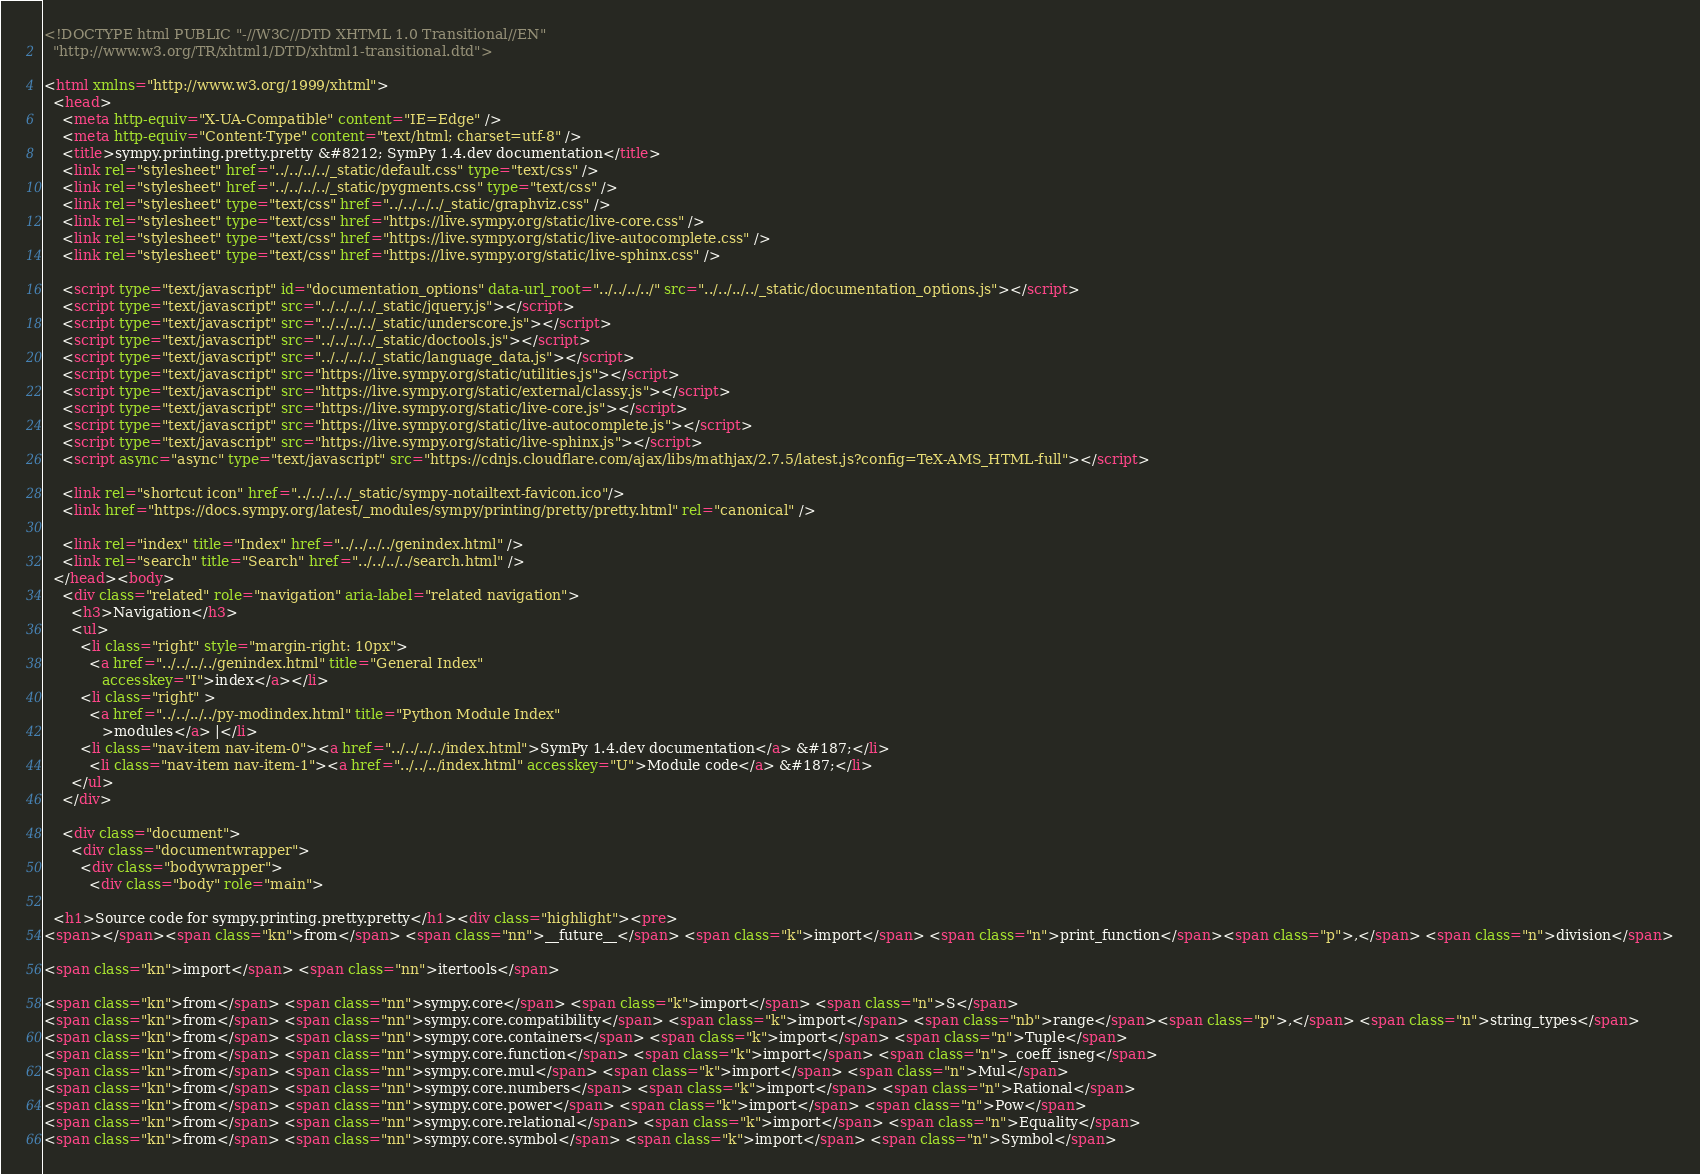<code> <loc_0><loc_0><loc_500><loc_500><_HTML_>
<!DOCTYPE html PUBLIC "-//W3C//DTD XHTML 1.0 Transitional//EN"
  "http://www.w3.org/TR/xhtml1/DTD/xhtml1-transitional.dtd">

<html xmlns="http://www.w3.org/1999/xhtml">
  <head>
    <meta http-equiv="X-UA-Compatible" content="IE=Edge" />
    <meta http-equiv="Content-Type" content="text/html; charset=utf-8" />
    <title>sympy.printing.pretty.pretty &#8212; SymPy 1.4.dev documentation</title>
    <link rel="stylesheet" href="../../../../_static/default.css" type="text/css" />
    <link rel="stylesheet" href="../../../../_static/pygments.css" type="text/css" />
    <link rel="stylesheet" type="text/css" href="../../../../_static/graphviz.css" />
    <link rel="stylesheet" type="text/css" href="https://live.sympy.org/static/live-core.css" />
    <link rel="stylesheet" type="text/css" href="https://live.sympy.org/static/live-autocomplete.css" />
    <link rel="stylesheet" type="text/css" href="https://live.sympy.org/static/live-sphinx.css" />
    
    <script type="text/javascript" id="documentation_options" data-url_root="../../../../" src="../../../../_static/documentation_options.js"></script>
    <script type="text/javascript" src="../../../../_static/jquery.js"></script>
    <script type="text/javascript" src="../../../../_static/underscore.js"></script>
    <script type="text/javascript" src="../../../../_static/doctools.js"></script>
    <script type="text/javascript" src="../../../../_static/language_data.js"></script>
    <script type="text/javascript" src="https://live.sympy.org/static/utilities.js"></script>
    <script type="text/javascript" src="https://live.sympy.org/static/external/classy.js"></script>
    <script type="text/javascript" src="https://live.sympy.org/static/live-core.js"></script>
    <script type="text/javascript" src="https://live.sympy.org/static/live-autocomplete.js"></script>
    <script type="text/javascript" src="https://live.sympy.org/static/live-sphinx.js"></script>
    <script async="async" type="text/javascript" src="https://cdnjs.cloudflare.com/ajax/libs/mathjax/2.7.5/latest.js?config=TeX-AMS_HTML-full"></script>
    
    <link rel="shortcut icon" href="../../../../_static/sympy-notailtext-favicon.ico"/>
    <link href="https://docs.sympy.org/latest/_modules/sympy/printing/pretty/pretty.html" rel="canonical" />
    
    <link rel="index" title="Index" href="../../../../genindex.html" />
    <link rel="search" title="Search" href="../../../../search.html" /> 
  </head><body>
    <div class="related" role="navigation" aria-label="related navigation">
      <h3>Navigation</h3>
      <ul>
        <li class="right" style="margin-right: 10px">
          <a href="../../../../genindex.html" title="General Index"
             accesskey="I">index</a></li>
        <li class="right" >
          <a href="../../../../py-modindex.html" title="Python Module Index"
             >modules</a> |</li>
        <li class="nav-item nav-item-0"><a href="../../../../index.html">SymPy 1.4.dev documentation</a> &#187;</li>
          <li class="nav-item nav-item-1"><a href="../../../index.html" accesskey="U">Module code</a> &#187;</li> 
      </ul>
    </div>  

    <div class="document">
      <div class="documentwrapper">
        <div class="bodywrapper">
          <div class="body" role="main">
            
  <h1>Source code for sympy.printing.pretty.pretty</h1><div class="highlight"><pre>
<span></span><span class="kn">from</span> <span class="nn">__future__</span> <span class="k">import</span> <span class="n">print_function</span><span class="p">,</span> <span class="n">division</span>

<span class="kn">import</span> <span class="nn">itertools</span>

<span class="kn">from</span> <span class="nn">sympy.core</span> <span class="k">import</span> <span class="n">S</span>
<span class="kn">from</span> <span class="nn">sympy.core.compatibility</span> <span class="k">import</span> <span class="nb">range</span><span class="p">,</span> <span class="n">string_types</span>
<span class="kn">from</span> <span class="nn">sympy.core.containers</span> <span class="k">import</span> <span class="n">Tuple</span>
<span class="kn">from</span> <span class="nn">sympy.core.function</span> <span class="k">import</span> <span class="n">_coeff_isneg</span>
<span class="kn">from</span> <span class="nn">sympy.core.mul</span> <span class="k">import</span> <span class="n">Mul</span>
<span class="kn">from</span> <span class="nn">sympy.core.numbers</span> <span class="k">import</span> <span class="n">Rational</span>
<span class="kn">from</span> <span class="nn">sympy.core.power</span> <span class="k">import</span> <span class="n">Pow</span>
<span class="kn">from</span> <span class="nn">sympy.core.relational</span> <span class="k">import</span> <span class="n">Equality</span>
<span class="kn">from</span> <span class="nn">sympy.core.symbol</span> <span class="k">import</span> <span class="n">Symbol</span></code> 